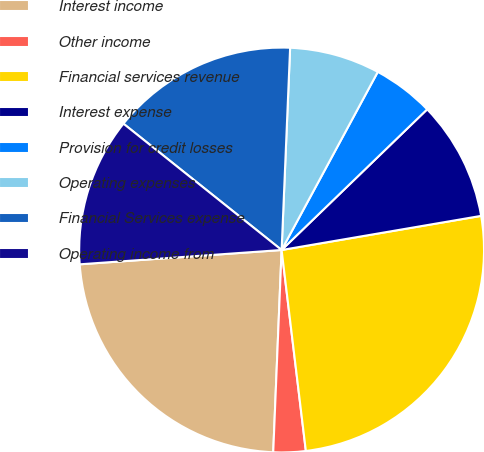<chart> <loc_0><loc_0><loc_500><loc_500><pie_chart><fcel>Interest income<fcel>Other income<fcel>Financial services revenue<fcel>Interest expense<fcel>Provision for credit losses<fcel>Operating expenses<fcel>Financial Services expense<fcel>Operating income from<nl><fcel>23.21%<fcel>2.57%<fcel>25.78%<fcel>9.53%<fcel>4.89%<fcel>7.21%<fcel>14.94%<fcel>11.85%<nl></chart> 